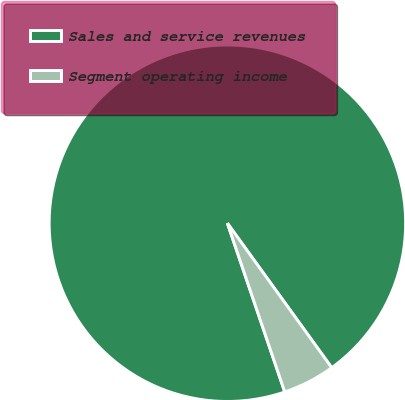Convert chart. <chart><loc_0><loc_0><loc_500><loc_500><pie_chart><fcel>Sales and service revenues<fcel>Segment operating income<nl><fcel>95.26%<fcel>4.74%<nl></chart> 